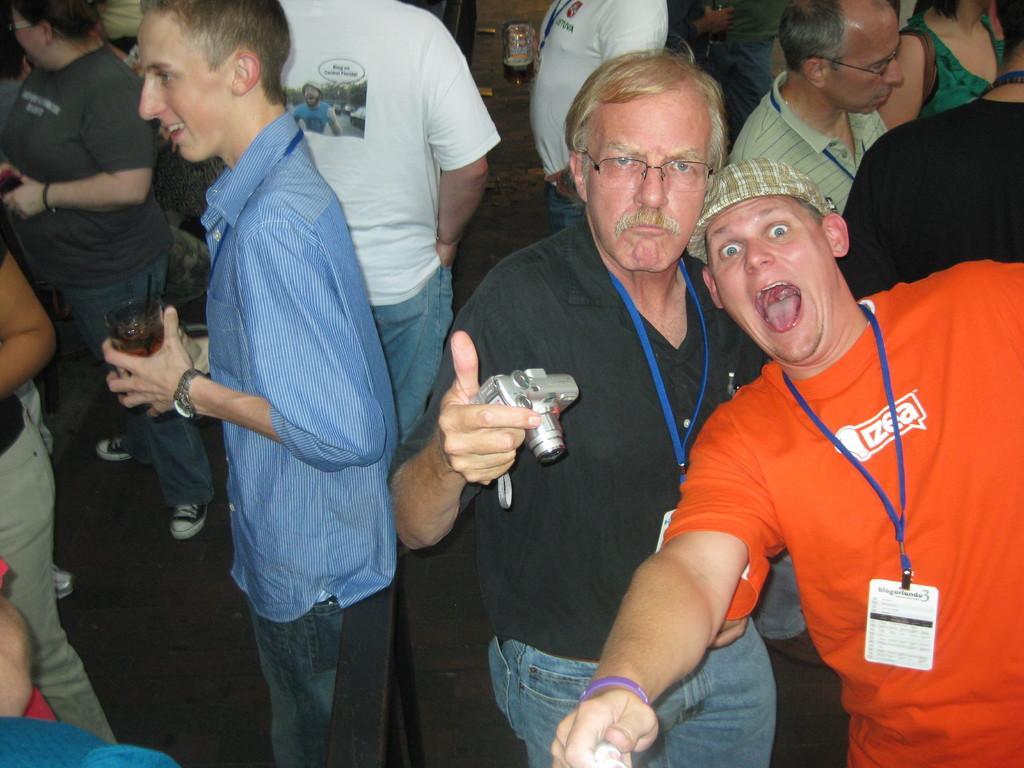In one or two sentences, can you explain what this image depicts? In this image we can see a group of people. We can see a man standing in the middle of this image is holding a camera. 